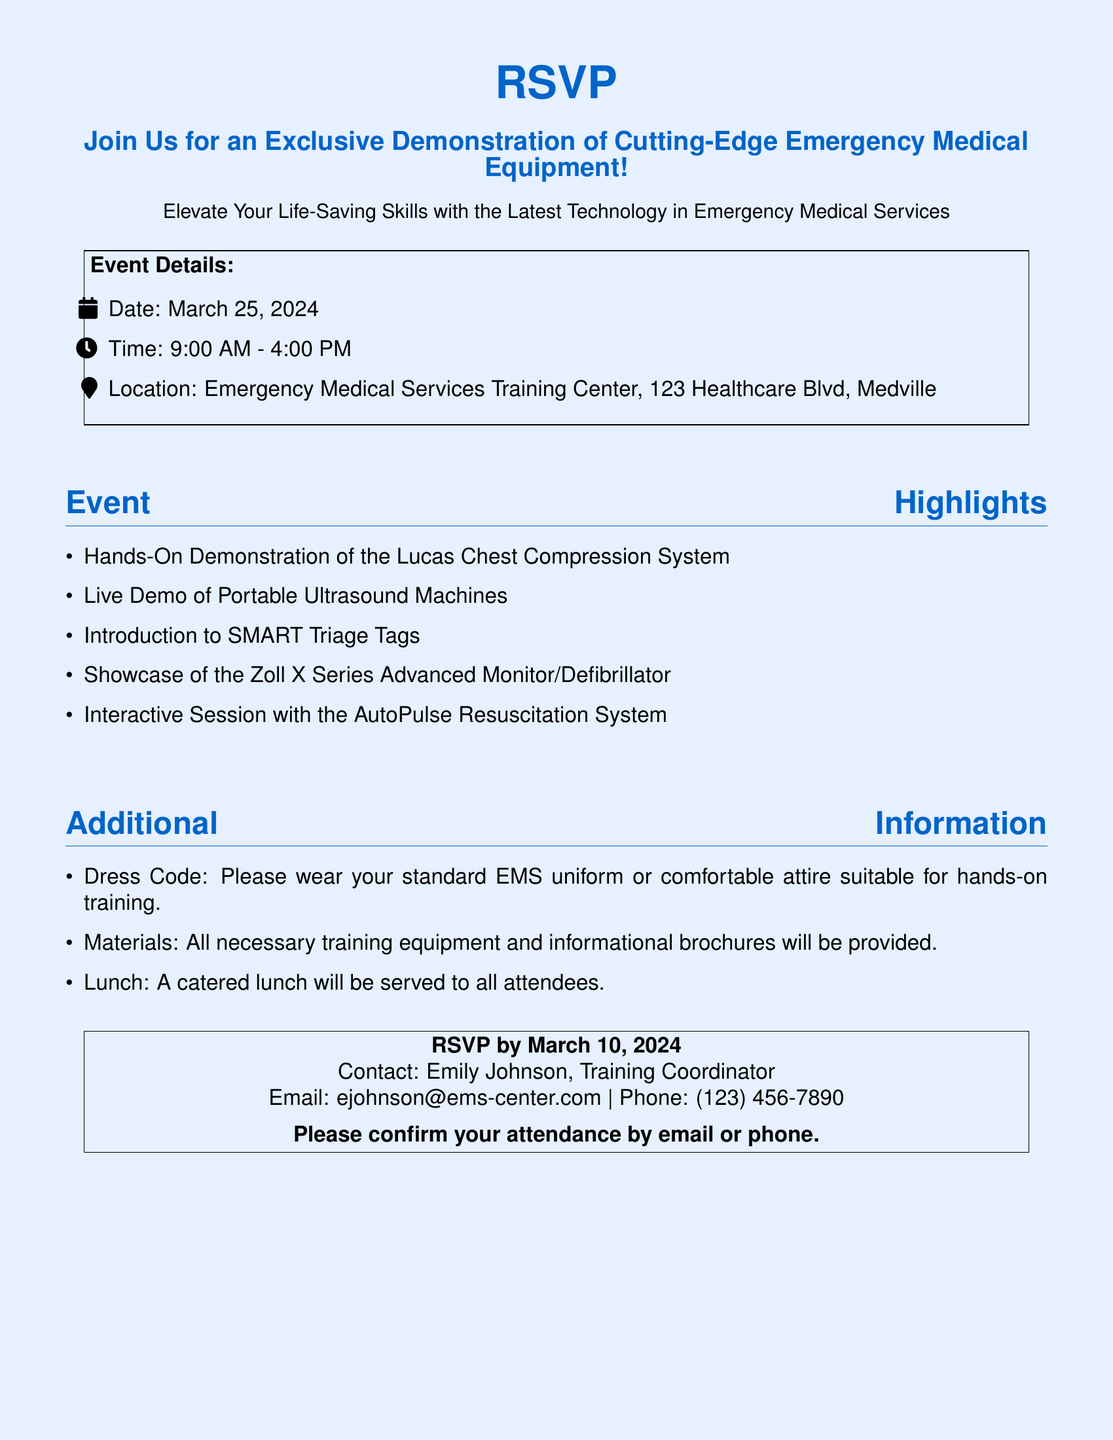What is the date of the event? The date of the event is provided in the document, indicating when the demonstration will take place.
Answer: March 25, 2024 What is the location of the event? The location is specified to help attendees know where the demonstration will occur.
Answer: Emergency Medical Services Training Center, 123 Healthcare Blvd, Medville What time does the event start? The starting time is mentioned to inform attendees when to arrive for the demonstration.
Answer: 9:00 AM Who is the contact person for the event? The document lists a contact person for attendees to reach out for inquiries or RSVP.
Answer: Emily Johnson What type of meal will be served? The document mentions what kind of meal is expected to be provided during the event.
Answer: A catered lunch How many hours is the event scheduled for? The total duration of the event is highlighted in the document for planning purposes.
Answer: 7 hours What is one of the equipment being demonstrated? The document lists specific advanced equipment that will be showcased during the event.
Answer: Lucas Chest Compression System What is the dress code for the event? The dress code is outlined to ensure attendees are appropriately dressed for the demonstration.
Answer: Standard EMS uniform or comfortable attire What is the RSVP deadline? The document specifies a deadline for attendees to confirm their participation in the event.
Answer: March 10, 2024 